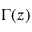<formula> <loc_0><loc_0><loc_500><loc_500>\Gamma ( z )</formula> 